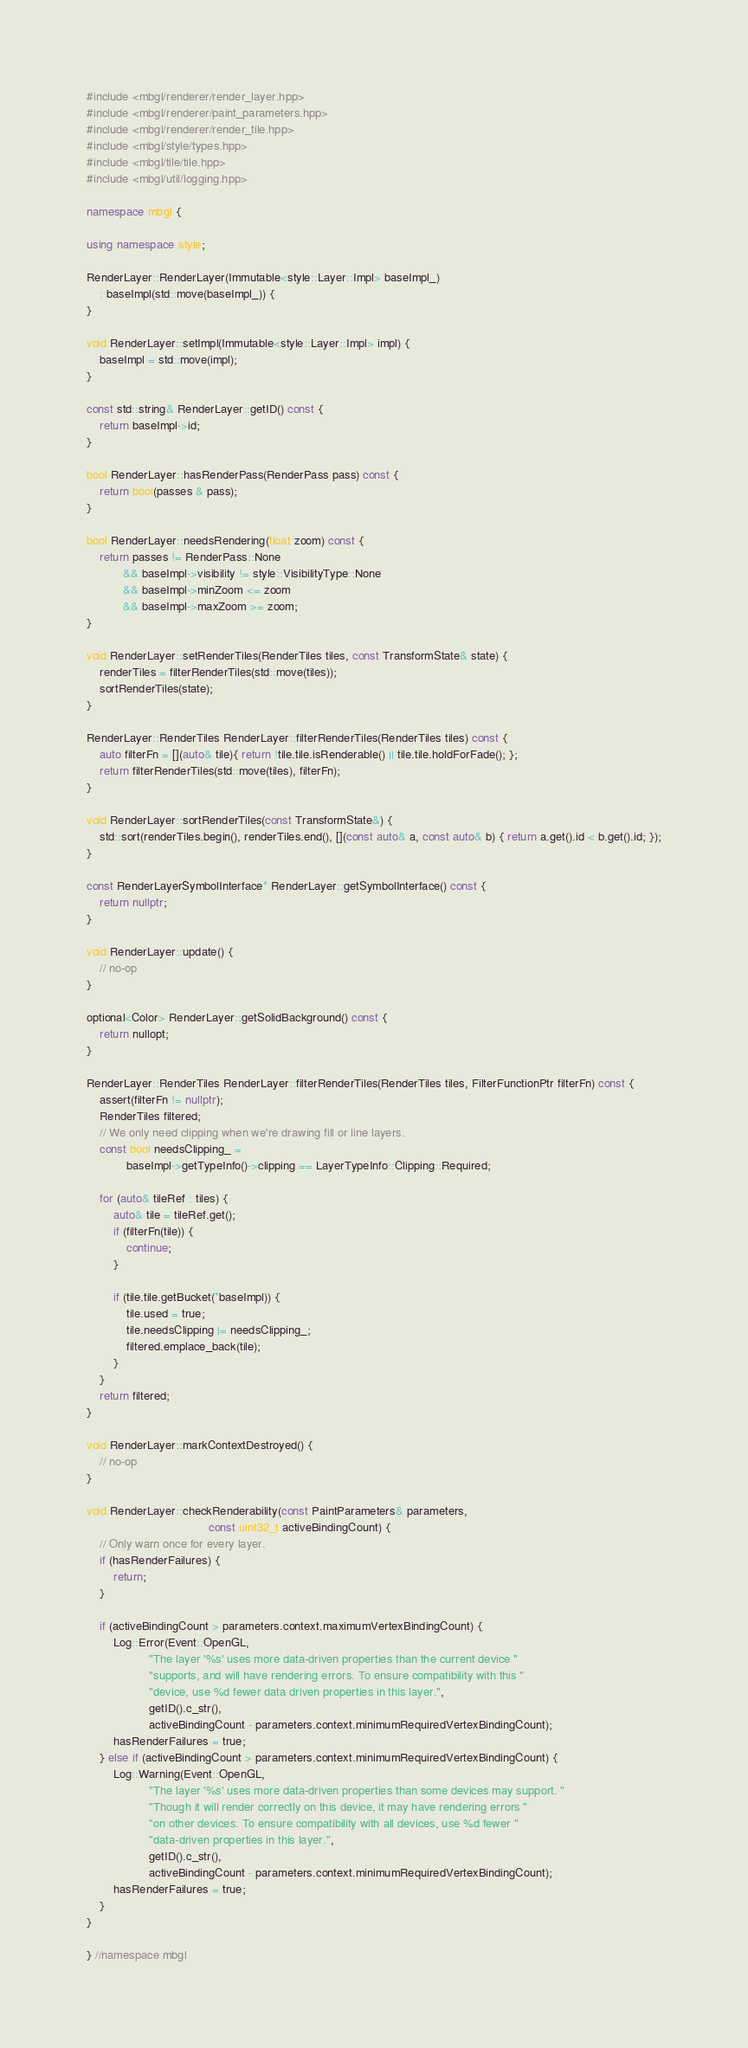Convert code to text. <code><loc_0><loc_0><loc_500><loc_500><_C++_>#include <mbgl/renderer/render_layer.hpp>
#include <mbgl/renderer/paint_parameters.hpp>
#include <mbgl/renderer/render_tile.hpp>
#include <mbgl/style/types.hpp>
#include <mbgl/tile/tile.hpp>
#include <mbgl/util/logging.hpp>

namespace mbgl {

using namespace style;

RenderLayer::RenderLayer(Immutable<style::Layer::Impl> baseImpl_)
    : baseImpl(std::move(baseImpl_)) {
}

void RenderLayer::setImpl(Immutable<style::Layer::Impl> impl) {
    baseImpl = std::move(impl);
}

const std::string& RenderLayer::getID() const {
    return baseImpl->id;
}

bool RenderLayer::hasRenderPass(RenderPass pass) const {
    return bool(passes & pass);
}

bool RenderLayer::needsRendering(float zoom) const {
    return passes != RenderPass::None
           && baseImpl->visibility != style::VisibilityType::None
           && baseImpl->minZoom <= zoom
           && baseImpl->maxZoom >= zoom;
}

void RenderLayer::setRenderTiles(RenderTiles tiles, const TransformState& state) {
    renderTiles = filterRenderTiles(std::move(tiles));
    sortRenderTiles(state);
}

RenderLayer::RenderTiles RenderLayer::filterRenderTiles(RenderTiles tiles) const {
    auto filterFn = [](auto& tile){ return !tile.tile.isRenderable() || tile.tile.holdForFade(); };
    return filterRenderTiles(std::move(tiles), filterFn);
}

void RenderLayer::sortRenderTiles(const TransformState&) {
    std::sort(renderTiles.begin(), renderTiles.end(), [](const auto& a, const auto& b) { return a.get().id < b.get().id; });
}

const RenderLayerSymbolInterface* RenderLayer::getSymbolInterface() const {
    return nullptr;
}

void RenderLayer::update() {
    // no-op
}

optional<Color> RenderLayer::getSolidBackground() const {
    return nullopt;
}

RenderLayer::RenderTiles RenderLayer::filterRenderTiles(RenderTiles tiles, FilterFunctionPtr filterFn) const {
    assert(filterFn != nullptr);
    RenderTiles filtered;
    // We only need clipping when we're drawing fill or line layers.
    const bool needsClipping_ =
            baseImpl->getTypeInfo()->clipping == LayerTypeInfo::Clipping::Required;

    for (auto& tileRef : tiles) {
        auto& tile = tileRef.get();
        if (filterFn(tile)) {
            continue;
        }

        if (tile.tile.getBucket(*baseImpl)) {
            tile.used = true;
            tile.needsClipping |= needsClipping_;
            filtered.emplace_back(tile);
        }
    }
    return filtered;
}

void RenderLayer::markContextDestroyed() {
    // no-op
}

void RenderLayer::checkRenderability(const PaintParameters& parameters,
                                     const uint32_t activeBindingCount) {
    // Only warn once for every layer.
    if (hasRenderFailures) {
        return;
    }

    if (activeBindingCount > parameters.context.maximumVertexBindingCount) {
        Log::Error(Event::OpenGL,
                   "The layer '%s' uses more data-driven properties than the current device "
                   "supports, and will have rendering errors. To ensure compatibility with this "
                   "device, use %d fewer data driven properties in this layer.",
                   getID().c_str(),
                   activeBindingCount - parameters.context.minimumRequiredVertexBindingCount);
        hasRenderFailures = true;
    } else if (activeBindingCount > parameters.context.minimumRequiredVertexBindingCount) {
        Log::Warning(Event::OpenGL,
                   "The layer '%s' uses more data-driven properties than some devices may support. "
                   "Though it will render correctly on this device, it may have rendering errors "
                   "on other devices. To ensure compatibility with all devices, use %d fewer "
                   "data-driven properties in this layer.",
                   getID().c_str(),
                   activeBindingCount - parameters.context.minimumRequiredVertexBindingCount);
        hasRenderFailures = true;
    }
}

} //namespace mbgl

</code> 